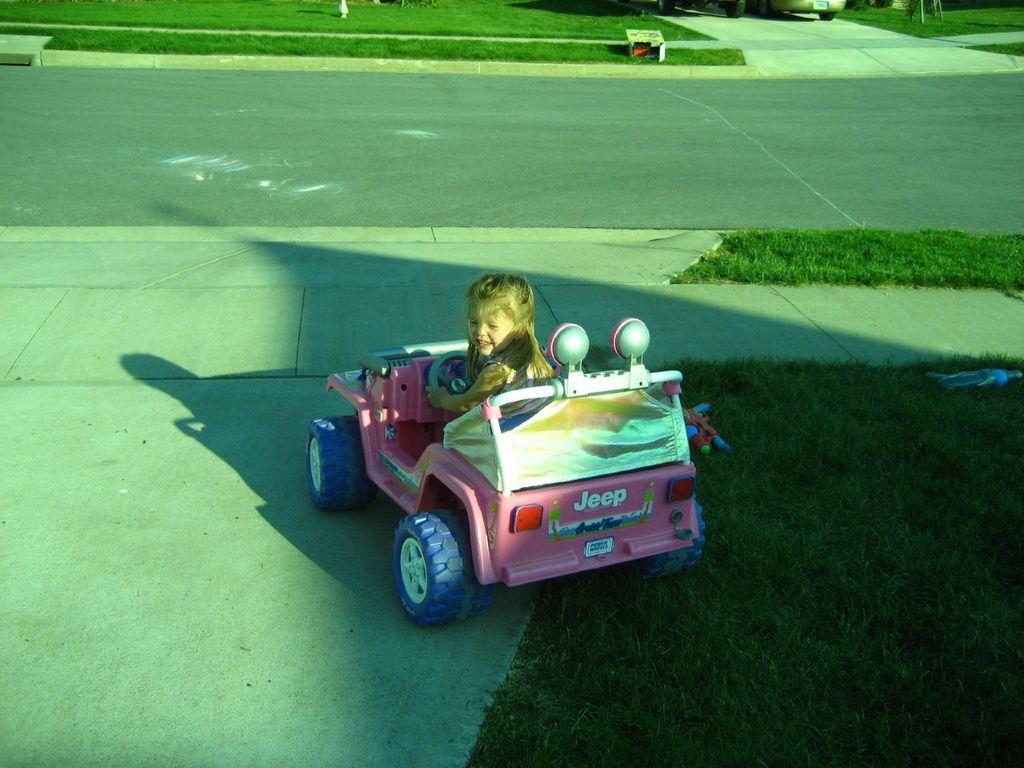Who is the main subject in the image? There is a small girl in the image. What is the girl doing in the image? The girl is sitting in a pink color car toy. What can be seen in the background of the image? There is a grass lawn and a small road lane in the background of the image. What type of pets are visible in the image? There are no pets visible in the image. Can you tell me how many bananas the girl is holding in the image? The girl is not holding any bananas in the image. 